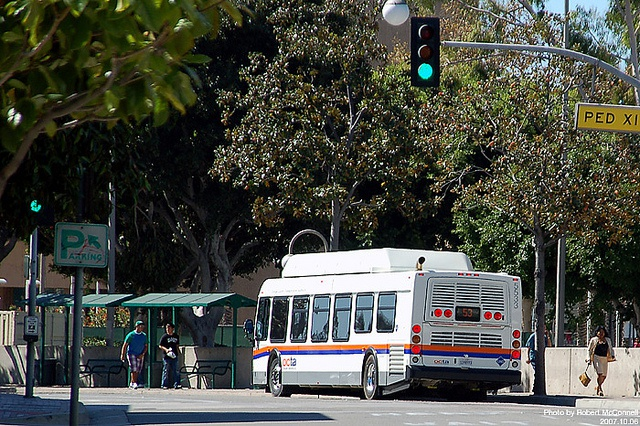Describe the objects in this image and their specific colors. I can see bus in black, white, darkgray, and gray tones, traffic light in black, cyan, gray, and white tones, people in black, navy, maroon, and gray tones, people in black, gray, and maroon tones, and people in black, gray, maroon, and navy tones in this image. 